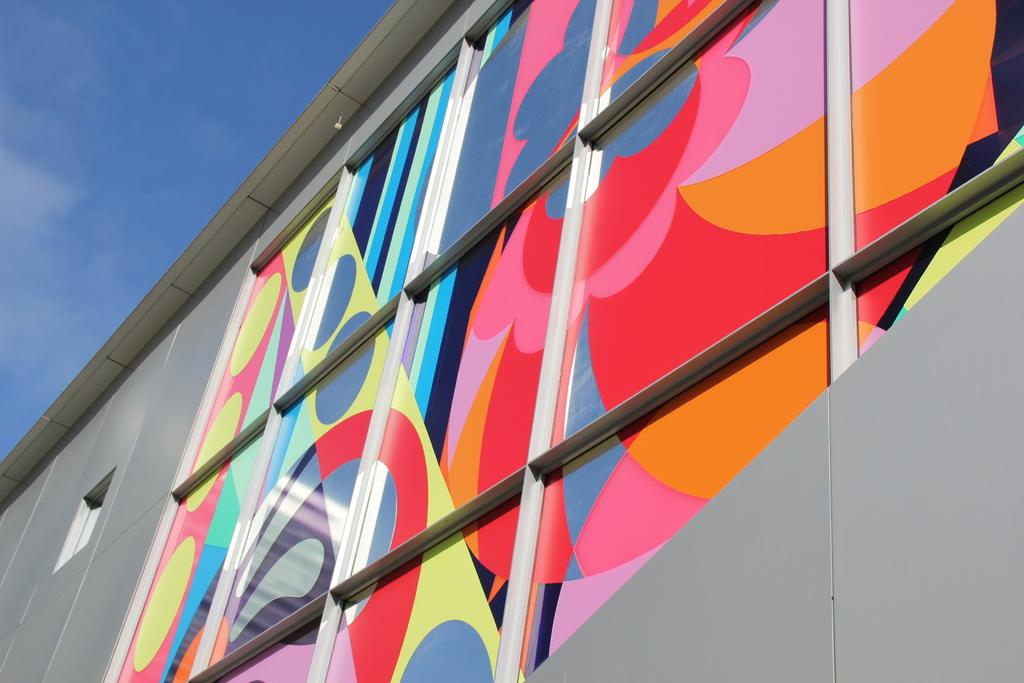What type of structure is visible in the image? There is a building in the image. What features can be observed on the building? The building has a roof and windows. What material is used for the windows? The windows have glass. Are there any decorations on the windows? Yes, there are paintings on the windows. What can be seen in the background of the image? There are clouds in the background of the image, and the sky is blue. What type of club can be seen in the hands of the person in the image? There is no person or club present in the image; it features a building with windows and a blue sky in the background. 